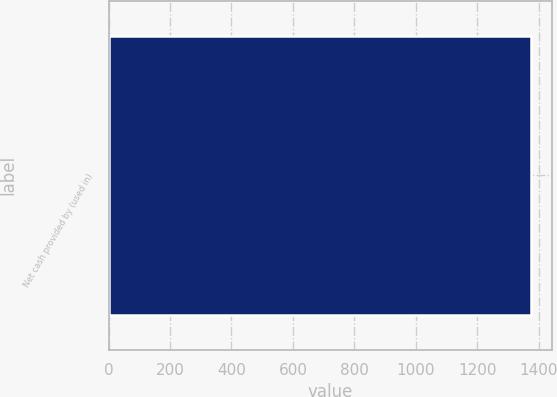<chart> <loc_0><loc_0><loc_500><loc_500><bar_chart><fcel>Net cash provided by (used in)<nl><fcel>1373.3<nl></chart> 